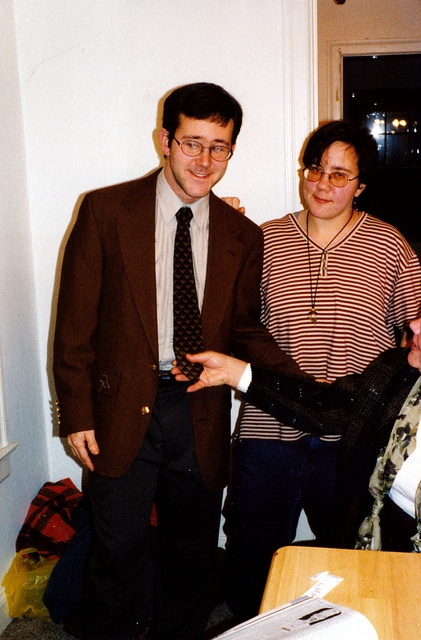Describe the objects in this image and their specific colors. I can see people in lightgray, black, maroon, tan, and salmon tones, people in lightgray, maroon, black, and tan tones, people in lightgray, black, white, tan, and darkgray tones, dining table in lightgray, orange, and tan tones, and backpack in lightgray, black, maroon, and olive tones in this image. 